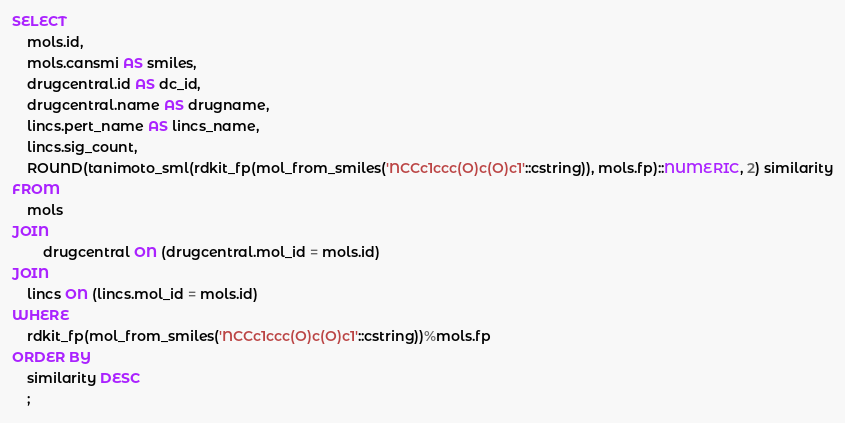<code> <loc_0><loc_0><loc_500><loc_500><_SQL_>SELECT
	mols.id,
	mols.cansmi AS smiles,
	drugcentral.id AS dc_id,
	drugcentral.name AS drugname,
	lincs.pert_name AS lincs_name,
	lincs.sig_count,
	ROUND(tanimoto_sml(rdkit_fp(mol_from_smiles('NCCc1ccc(O)c(O)c1'::cstring)), mols.fp)::NUMERIC, 2) similarity
FROM
	mols
JOIN
        drugcentral ON (drugcentral.mol_id = mols.id)
JOIN
	lincs ON (lincs.mol_id = mols.id)
WHERE
	rdkit_fp(mol_from_smiles('NCCc1ccc(O)c(O)c1'::cstring))%mols.fp
ORDER BY
	similarity DESC
	;
</code> 